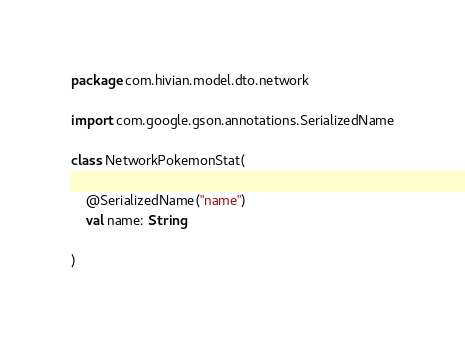Convert code to text. <code><loc_0><loc_0><loc_500><loc_500><_Kotlin_>package com.hivian.model.dto.network

import com.google.gson.annotations.SerializedName

class NetworkPokemonStat(

    @SerializedName("name")
    val name: String

)
</code> 